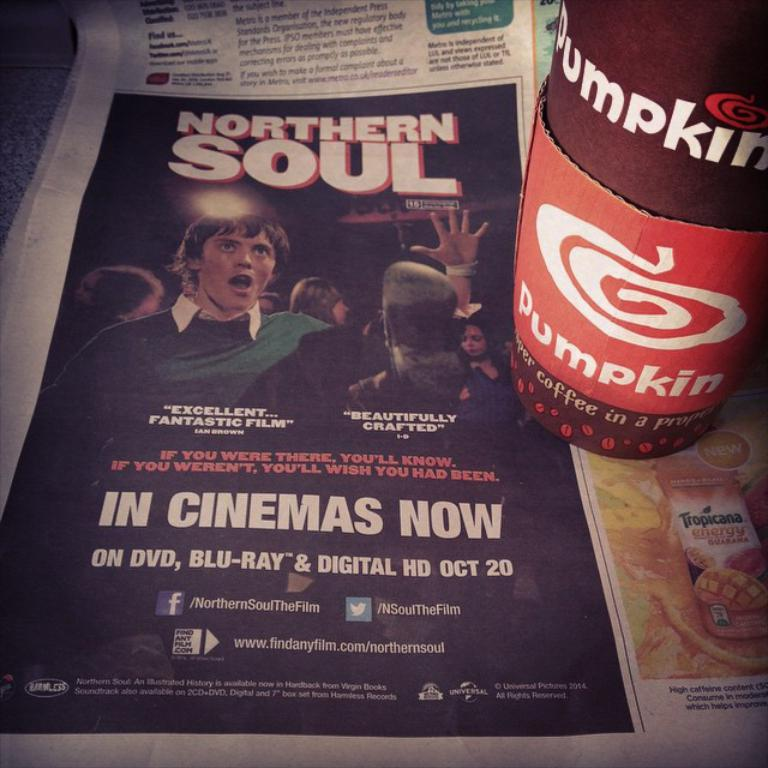What is the main object in the image? There is a newspaper in the image. What can be found on the newspaper? The newspaper contains text and pictures. What is located on the right side of the image? There are cups with cardboard on the right side of the image. Can you tell me how many ladybugs are crawling on the newspaper in the image? There are no ladybugs present in the image; it only features a newspaper, text, pictures, and cups with cardboard. 